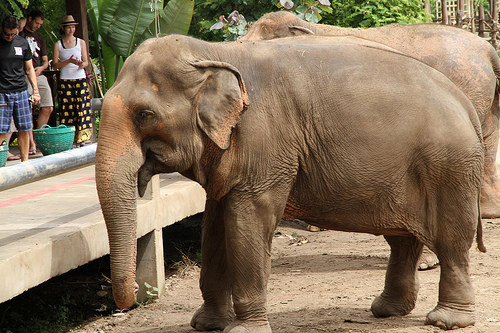Imagine the elephant could talk. What might it be saying? Looking at the expressions of the elephant, it might say something like, 'Hello there! I'm just relaxing here, enjoying the wonderful weather and the company of the visitors. Feel free to watch me, but please don't disturb my peaceful moment.' Can you describe an imaginary adventure that the elephant might go on if it could leave the zoo? Sure! If the elephant could leave the zoo, it might embark on an adventurous journey through the jungle. It would wander through dense forests, fording rivers and encountering all sorts of animals – from mischievous monkeys to majestic tigers. Along the way, it would gather stories and experiences, making friends with other animals and helping them overcome challenges. Ultimately, it would return to the zoo with a treasure trove of tales and wisdom to share with its fellow zoo inhabitants. 